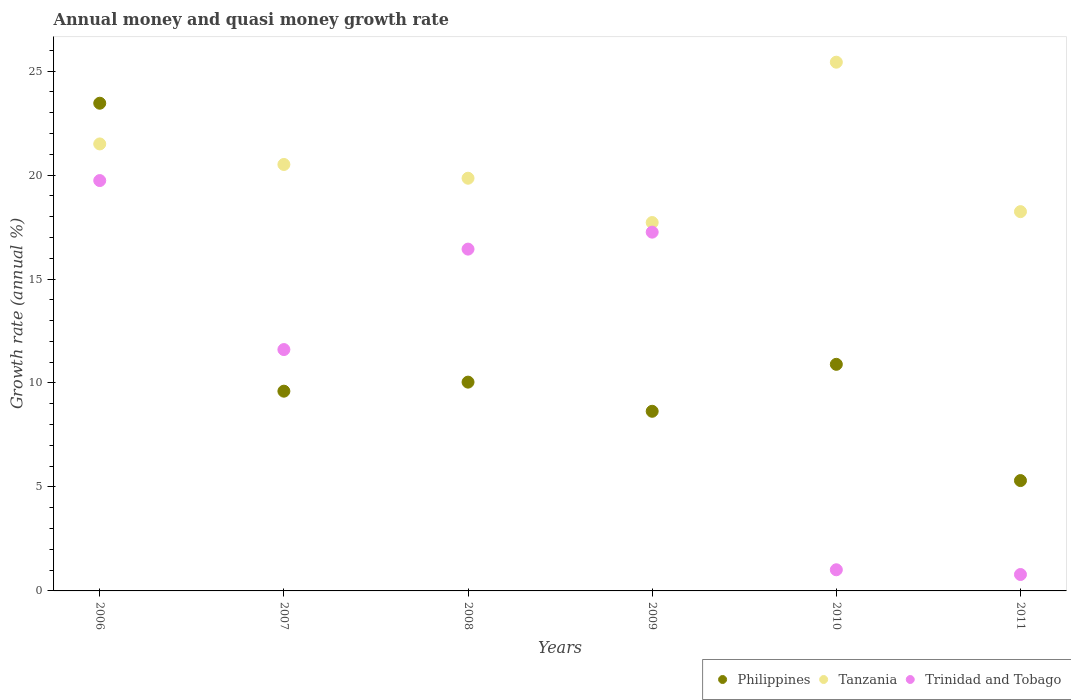What is the growth rate in Trinidad and Tobago in 2006?
Your answer should be compact. 19.73. Across all years, what is the maximum growth rate in Tanzania?
Keep it short and to the point. 25.43. Across all years, what is the minimum growth rate in Trinidad and Tobago?
Make the answer very short. 0.79. In which year was the growth rate in Tanzania maximum?
Your response must be concise. 2010. What is the total growth rate in Philippines in the graph?
Offer a terse response. 67.94. What is the difference between the growth rate in Tanzania in 2010 and that in 2011?
Give a very brief answer. 7.19. What is the difference between the growth rate in Trinidad and Tobago in 2006 and the growth rate in Tanzania in 2011?
Your response must be concise. 1.49. What is the average growth rate in Trinidad and Tobago per year?
Give a very brief answer. 11.14. In the year 2010, what is the difference between the growth rate in Philippines and growth rate in Tanzania?
Your answer should be compact. -14.53. What is the ratio of the growth rate in Philippines in 2006 to that in 2008?
Offer a very short reply. 2.34. Is the difference between the growth rate in Philippines in 2006 and 2011 greater than the difference between the growth rate in Tanzania in 2006 and 2011?
Keep it short and to the point. Yes. What is the difference between the highest and the second highest growth rate in Tanzania?
Offer a very short reply. 3.93. What is the difference between the highest and the lowest growth rate in Trinidad and Tobago?
Offer a very short reply. 18.94. In how many years, is the growth rate in Trinidad and Tobago greater than the average growth rate in Trinidad and Tobago taken over all years?
Offer a terse response. 4. Is the sum of the growth rate in Trinidad and Tobago in 2007 and 2010 greater than the maximum growth rate in Tanzania across all years?
Give a very brief answer. No. Is it the case that in every year, the sum of the growth rate in Trinidad and Tobago and growth rate in Philippines  is greater than the growth rate in Tanzania?
Your response must be concise. No. Does the growth rate in Tanzania monotonically increase over the years?
Provide a succinct answer. No. How many years are there in the graph?
Provide a succinct answer. 6. What is the difference between two consecutive major ticks on the Y-axis?
Your response must be concise. 5. Are the values on the major ticks of Y-axis written in scientific E-notation?
Offer a very short reply. No. Does the graph contain grids?
Your answer should be compact. No. What is the title of the graph?
Provide a succinct answer. Annual money and quasi money growth rate. Does "Venezuela" appear as one of the legend labels in the graph?
Make the answer very short. No. What is the label or title of the X-axis?
Your answer should be very brief. Years. What is the label or title of the Y-axis?
Give a very brief answer. Growth rate (annual %). What is the Growth rate (annual %) of Philippines in 2006?
Offer a very short reply. 23.45. What is the Growth rate (annual %) of Tanzania in 2006?
Provide a succinct answer. 21.5. What is the Growth rate (annual %) in Trinidad and Tobago in 2006?
Offer a very short reply. 19.73. What is the Growth rate (annual %) in Philippines in 2007?
Offer a very short reply. 9.61. What is the Growth rate (annual %) of Tanzania in 2007?
Your answer should be compact. 20.51. What is the Growth rate (annual %) of Trinidad and Tobago in 2007?
Give a very brief answer. 11.61. What is the Growth rate (annual %) in Philippines in 2008?
Your answer should be compact. 10.04. What is the Growth rate (annual %) of Tanzania in 2008?
Provide a short and direct response. 19.85. What is the Growth rate (annual %) of Trinidad and Tobago in 2008?
Make the answer very short. 16.44. What is the Growth rate (annual %) in Philippines in 2009?
Offer a very short reply. 8.64. What is the Growth rate (annual %) of Tanzania in 2009?
Your answer should be very brief. 17.72. What is the Growth rate (annual %) in Trinidad and Tobago in 2009?
Offer a very short reply. 17.25. What is the Growth rate (annual %) in Philippines in 2010?
Your answer should be compact. 10.9. What is the Growth rate (annual %) of Tanzania in 2010?
Keep it short and to the point. 25.43. What is the Growth rate (annual %) of Trinidad and Tobago in 2010?
Provide a short and direct response. 1.02. What is the Growth rate (annual %) of Philippines in 2011?
Give a very brief answer. 5.31. What is the Growth rate (annual %) in Tanzania in 2011?
Provide a short and direct response. 18.24. What is the Growth rate (annual %) of Trinidad and Tobago in 2011?
Offer a very short reply. 0.79. Across all years, what is the maximum Growth rate (annual %) of Philippines?
Your response must be concise. 23.45. Across all years, what is the maximum Growth rate (annual %) of Tanzania?
Your answer should be very brief. 25.43. Across all years, what is the maximum Growth rate (annual %) of Trinidad and Tobago?
Offer a terse response. 19.73. Across all years, what is the minimum Growth rate (annual %) of Philippines?
Your answer should be compact. 5.31. Across all years, what is the minimum Growth rate (annual %) of Tanzania?
Your response must be concise. 17.72. Across all years, what is the minimum Growth rate (annual %) in Trinidad and Tobago?
Ensure brevity in your answer.  0.79. What is the total Growth rate (annual %) of Philippines in the graph?
Provide a short and direct response. 67.94. What is the total Growth rate (annual %) in Tanzania in the graph?
Give a very brief answer. 123.23. What is the total Growth rate (annual %) of Trinidad and Tobago in the graph?
Your response must be concise. 66.84. What is the difference between the Growth rate (annual %) in Philippines in 2006 and that in 2007?
Your answer should be very brief. 13.85. What is the difference between the Growth rate (annual %) of Trinidad and Tobago in 2006 and that in 2007?
Give a very brief answer. 8.13. What is the difference between the Growth rate (annual %) in Philippines in 2006 and that in 2008?
Make the answer very short. 13.41. What is the difference between the Growth rate (annual %) of Tanzania in 2006 and that in 2008?
Give a very brief answer. 1.65. What is the difference between the Growth rate (annual %) in Trinidad and Tobago in 2006 and that in 2008?
Make the answer very short. 3.3. What is the difference between the Growth rate (annual %) in Philippines in 2006 and that in 2009?
Provide a succinct answer. 14.82. What is the difference between the Growth rate (annual %) in Tanzania in 2006 and that in 2009?
Ensure brevity in your answer.  3.78. What is the difference between the Growth rate (annual %) of Trinidad and Tobago in 2006 and that in 2009?
Make the answer very short. 2.48. What is the difference between the Growth rate (annual %) in Philippines in 2006 and that in 2010?
Your answer should be very brief. 12.56. What is the difference between the Growth rate (annual %) of Tanzania in 2006 and that in 2010?
Provide a short and direct response. -3.93. What is the difference between the Growth rate (annual %) of Trinidad and Tobago in 2006 and that in 2010?
Your answer should be very brief. 18.72. What is the difference between the Growth rate (annual %) in Philippines in 2006 and that in 2011?
Provide a succinct answer. 18.15. What is the difference between the Growth rate (annual %) in Tanzania in 2006 and that in 2011?
Ensure brevity in your answer.  3.26. What is the difference between the Growth rate (annual %) of Trinidad and Tobago in 2006 and that in 2011?
Give a very brief answer. 18.94. What is the difference between the Growth rate (annual %) in Philippines in 2007 and that in 2008?
Your answer should be compact. -0.44. What is the difference between the Growth rate (annual %) of Tanzania in 2007 and that in 2008?
Provide a succinct answer. 0.66. What is the difference between the Growth rate (annual %) of Trinidad and Tobago in 2007 and that in 2008?
Your answer should be compact. -4.83. What is the difference between the Growth rate (annual %) in Philippines in 2007 and that in 2009?
Offer a very short reply. 0.97. What is the difference between the Growth rate (annual %) in Tanzania in 2007 and that in 2009?
Provide a succinct answer. 2.79. What is the difference between the Growth rate (annual %) of Trinidad and Tobago in 2007 and that in 2009?
Make the answer very short. -5.65. What is the difference between the Growth rate (annual %) of Philippines in 2007 and that in 2010?
Make the answer very short. -1.29. What is the difference between the Growth rate (annual %) in Tanzania in 2007 and that in 2010?
Your response must be concise. -4.92. What is the difference between the Growth rate (annual %) of Trinidad and Tobago in 2007 and that in 2010?
Your answer should be compact. 10.59. What is the difference between the Growth rate (annual %) in Philippines in 2007 and that in 2011?
Make the answer very short. 4.3. What is the difference between the Growth rate (annual %) of Tanzania in 2007 and that in 2011?
Offer a very short reply. 2.27. What is the difference between the Growth rate (annual %) in Trinidad and Tobago in 2007 and that in 2011?
Offer a very short reply. 10.82. What is the difference between the Growth rate (annual %) in Philippines in 2008 and that in 2009?
Your answer should be compact. 1.4. What is the difference between the Growth rate (annual %) of Tanzania in 2008 and that in 2009?
Offer a very short reply. 2.13. What is the difference between the Growth rate (annual %) in Trinidad and Tobago in 2008 and that in 2009?
Make the answer very short. -0.82. What is the difference between the Growth rate (annual %) of Philippines in 2008 and that in 2010?
Offer a terse response. -0.86. What is the difference between the Growth rate (annual %) in Tanzania in 2008 and that in 2010?
Your answer should be compact. -5.58. What is the difference between the Growth rate (annual %) in Trinidad and Tobago in 2008 and that in 2010?
Keep it short and to the point. 15.42. What is the difference between the Growth rate (annual %) of Philippines in 2008 and that in 2011?
Provide a succinct answer. 4.73. What is the difference between the Growth rate (annual %) of Tanzania in 2008 and that in 2011?
Your response must be concise. 1.61. What is the difference between the Growth rate (annual %) in Trinidad and Tobago in 2008 and that in 2011?
Your response must be concise. 15.65. What is the difference between the Growth rate (annual %) of Philippines in 2009 and that in 2010?
Your answer should be very brief. -2.26. What is the difference between the Growth rate (annual %) of Tanzania in 2009 and that in 2010?
Keep it short and to the point. -7.71. What is the difference between the Growth rate (annual %) of Trinidad and Tobago in 2009 and that in 2010?
Your answer should be very brief. 16.24. What is the difference between the Growth rate (annual %) of Philippines in 2009 and that in 2011?
Offer a very short reply. 3.33. What is the difference between the Growth rate (annual %) in Tanzania in 2009 and that in 2011?
Keep it short and to the point. -0.52. What is the difference between the Growth rate (annual %) of Trinidad and Tobago in 2009 and that in 2011?
Your answer should be very brief. 16.46. What is the difference between the Growth rate (annual %) in Philippines in 2010 and that in 2011?
Ensure brevity in your answer.  5.59. What is the difference between the Growth rate (annual %) in Tanzania in 2010 and that in 2011?
Ensure brevity in your answer.  7.19. What is the difference between the Growth rate (annual %) in Trinidad and Tobago in 2010 and that in 2011?
Offer a terse response. 0.23. What is the difference between the Growth rate (annual %) of Philippines in 2006 and the Growth rate (annual %) of Tanzania in 2007?
Offer a terse response. 2.95. What is the difference between the Growth rate (annual %) of Philippines in 2006 and the Growth rate (annual %) of Trinidad and Tobago in 2007?
Ensure brevity in your answer.  11.85. What is the difference between the Growth rate (annual %) of Tanzania in 2006 and the Growth rate (annual %) of Trinidad and Tobago in 2007?
Your response must be concise. 9.89. What is the difference between the Growth rate (annual %) in Philippines in 2006 and the Growth rate (annual %) in Tanzania in 2008?
Provide a succinct answer. 3.61. What is the difference between the Growth rate (annual %) in Philippines in 2006 and the Growth rate (annual %) in Trinidad and Tobago in 2008?
Provide a short and direct response. 7.02. What is the difference between the Growth rate (annual %) in Tanzania in 2006 and the Growth rate (annual %) in Trinidad and Tobago in 2008?
Provide a short and direct response. 5.06. What is the difference between the Growth rate (annual %) in Philippines in 2006 and the Growth rate (annual %) in Tanzania in 2009?
Give a very brief answer. 5.74. What is the difference between the Growth rate (annual %) in Philippines in 2006 and the Growth rate (annual %) in Trinidad and Tobago in 2009?
Give a very brief answer. 6.2. What is the difference between the Growth rate (annual %) in Tanzania in 2006 and the Growth rate (annual %) in Trinidad and Tobago in 2009?
Ensure brevity in your answer.  4.24. What is the difference between the Growth rate (annual %) in Philippines in 2006 and the Growth rate (annual %) in Tanzania in 2010?
Provide a short and direct response. -1.97. What is the difference between the Growth rate (annual %) of Philippines in 2006 and the Growth rate (annual %) of Trinidad and Tobago in 2010?
Your response must be concise. 22.44. What is the difference between the Growth rate (annual %) of Tanzania in 2006 and the Growth rate (annual %) of Trinidad and Tobago in 2010?
Ensure brevity in your answer.  20.48. What is the difference between the Growth rate (annual %) of Philippines in 2006 and the Growth rate (annual %) of Tanzania in 2011?
Make the answer very short. 5.21. What is the difference between the Growth rate (annual %) in Philippines in 2006 and the Growth rate (annual %) in Trinidad and Tobago in 2011?
Make the answer very short. 22.66. What is the difference between the Growth rate (annual %) of Tanzania in 2006 and the Growth rate (annual %) of Trinidad and Tobago in 2011?
Keep it short and to the point. 20.71. What is the difference between the Growth rate (annual %) in Philippines in 2007 and the Growth rate (annual %) in Tanzania in 2008?
Offer a terse response. -10.24. What is the difference between the Growth rate (annual %) in Philippines in 2007 and the Growth rate (annual %) in Trinidad and Tobago in 2008?
Offer a terse response. -6.83. What is the difference between the Growth rate (annual %) in Tanzania in 2007 and the Growth rate (annual %) in Trinidad and Tobago in 2008?
Provide a succinct answer. 4.07. What is the difference between the Growth rate (annual %) of Philippines in 2007 and the Growth rate (annual %) of Tanzania in 2009?
Ensure brevity in your answer.  -8.11. What is the difference between the Growth rate (annual %) of Philippines in 2007 and the Growth rate (annual %) of Trinidad and Tobago in 2009?
Your answer should be very brief. -7.65. What is the difference between the Growth rate (annual %) of Tanzania in 2007 and the Growth rate (annual %) of Trinidad and Tobago in 2009?
Make the answer very short. 3.25. What is the difference between the Growth rate (annual %) in Philippines in 2007 and the Growth rate (annual %) in Tanzania in 2010?
Keep it short and to the point. -15.82. What is the difference between the Growth rate (annual %) in Philippines in 2007 and the Growth rate (annual %) in Trinidad and Tobago in 2010?
Your answer should be very brief. 8.59. What is the difference between the Growth rate (annual %) of Tanzania in 2007 and the Growth rate (annual %) of Trinidad and Tobago in 2010?
Provide a succinct answer. 19.49. What is the difference between the Growth rate (annual %) of Philippines in 2007 and the Growth rate (annual %) of Tanzania in 2011?
Provide a succinct answer. -8.63. What is the difference between the Growth rate (annual %) in Philippines in 2007 and the Growth rate (annual %) in Trinidad and Tobago in 2011?
Offer a very short reply. 8.82. What is the difference between the Growth rate (annual %) of Tanzania in 2007 and the Growth rate (annual %) of Trinidad and Tobago in 2011?
Your answer should be compact. 19.72. What is the difference between the Growth rate (annual %) of Philippines in 2008 and the Growth rate (annual %) of Tanzania in 2009?
Your answer should be compact. -7.67. What is the difference between the Growth rate (annual %) of Philippines in 2008 and the Growth rate (annual %) of Trinidad and Tobago in 2009?
Your answer should be very brief. -7.21. What is the difference between the Growth rate (annual %) in Tanzania in 2008 and the Growth rate (annual %) in Trinidad and Tobago in 2009?
Provide a short and direct response. 2.59. What is the difference between the Growth rate (annual %) of Philippines in 2008 and the Growth rate (annual %) of Tanzania in 2010?
Provide a short and direct response. -15.39. What is the difference between the Growth rate (annual %) in Philippines in 2008 and the Growth rate (annual %) in Trinidad and Tobago in 2010?
Your response must be concise. 9.02. What is the difference between the Growth rate (annual %) in Tanzania in 2008 and the Growth rate (annual %) in Trinidad and Tobago in 2010?
Ensure brevity in your answer.  18.83. What is the difference between the Growth rate (annual %) in Philippines in 2008 and the Growth rate (annual %) in Tanzania in 2011?
Provide a short and direct response. -8.2. What is the difference between the Growth rate (annual %) in Philippines in 2008 and the Growth rate (annual %) in Trinidad and Tobago in 2011?
Provide a succinct answer. 9.25. What is the difference between the Growth rate (annual %) in Tanzania in 2008 and the Growth rate (annual %) in Trinidad and Tobago in 2011?
Your response must be concise. 19.06. What is the difference between the Growth rate (annual %) of Philippines in 2009 and the Growth rate (annual %) of Tanzania in 2010?
Give a very brief answer. -16.79. What is the difference between the Growth rate (annual %) of Philippines in 2009 and the Growth rate (annual %) of Trinidad and Tobago in 2010?
Provide a succinct answer. 7.62. What is the difference between the Growth rate (annual %) in Tanzania in 2009 and the Growth rate (annual %) in Trinidad and Tobago in 2010?
Offer a very short reply. 16.7. What is the difference between the Growth rate (annual %) of Philippines in 2009 and the Growth rate (annual %) of Tanzania in 2011?
Offer a terse response. -9.6. What is the difference between the Growth rate (annual %) of Philippines in 2009 and the Growth rate (annual %) of Trinidad and Tobago in 2011?
Your answer should be compact. 7.85. What is the difference between the Growth rate (annual %) in Tanzania in 2009 and the Growth rate (annual %) in Trinidad and Tobago in 2011?
Keep it short and to the point. 16.93. What is the difference between the Growth rate (annual %) in Philippines in 2010 and the Growth rate (annual %) in Tanzania in 2011?
Your answer should be very brief. -7.34. What is the difference between the Growth rate (annual %) of Philippines in 2010 and the Growth rate (annual %) of Trinidad and Tobago in 2011?
Give a very brief answer. 10.11. What is the difference between the Growth rate (annual %) of Tanzania in 2010 and the Growth rate (annual %) of Trinidad and Tobago in 2011?
Provide a short and direct response. 24.64. What is the average Growth rate (annual %) of Philippines per year?
Provide a succinct answer. 11.32. What is the average Growth rate (annual %) of Tanzania per year?
Your response must be concise. 20.54. What is the average Growth rate (annual %) of Trinidad and Tobago per year?
Provide a succinct answer. 11.14. In the year 2006, what is the difference between the Growth rate (annual %) in Philippines and Growth rate (annual %) in Tanzania?
Your answer should be compact. 1.96. In the year 2006, what is the difference between the Growth rate (annual %) of Philippines and Growth rate (annual %) of Trinidad and Tobago?
Provide a short and direct response. 3.72. In the year 2006, what is the difference between the Growth rate (annual %) in Tanzania and Growth rate (annual %) in Trinidad and Tobago?
Give a very brief answer. 1.76. In the year 2007, what is the difference between the Growth rate (annual %) in Philippines and Growth rate (annual %) in Tanzania?
Ensure brevity in your answer.  -10.9. In the year 2007, what is the difference between the Growth rate (annual %) in Philippines and Growth rate (annual %) in Trinidad and Tobago?
Ensure brevity in your answer.  -2. In the year 2007, what is the difference between the Growth rate (annual %) of Tanzania and Growth rate (annual %) of Trinidad and Tobago?
Your response must be concise. 8.9. In the year 2008, what is the difference between the Growth rate (annual %) of Philippines and Growth rate (annual %) of Tanzania?
Give a very brief answer. -9.81. In the year 2008, what is the difference between the Growth rate (annual %) in Philippines and Growth rate (annual %) in Trinidad and Tobago?
Your answer should be compact. -6.4. In the year 2008, what is the difference between the Growth rate (annual %) in Tanzania and Growth rate (annual %) in Trinidad and Tobago?
Provide a short and direct response. 3.41. In the year 2009, what is the difference between the Growth rate (annual %) of Philippines and Growth rate (annual %) of Tanzania?
Give a very brief answer. -9.08. In the year 2009, what is the difference between the Growth rate (annual %) of Philippines and Growth rate (annual %) of Trinidad and Tobago?
Offer a terse response. -8.62. In the year 2009, what is the difference between the Growth rate (annual %) of Tanzania and Growth rate (annual %) of Trinidad and Tobago?
Your answer should be compact. 0.46. In the year 2010, what is the difference between the Growth rate (annual %) in Philippines and Growth rate (annual %) in Tanzania?
Keep it short and to the point. -14.53. In the year 2010, what is the difference between the Growth rate (annual %) in Philippines and Growth rate (annual %) in Trinidad and Tobago?
Provide a succinct answer. 9.88. In the year 2010, what is the difference between the Growth rate (annual %) of Tanzania and Growth rate (annual %) of Trinidad and Tobago?
Offer a very short reply. 24.41. In the year 2011, what is the difference between the Growth rate (annual %) in Philippines and Growth rate (annual %) in Tanzania?
Make the answer very short. -12.93. In the year 2011, what is the difference between the Growth rate (annual %) in Philippines and Growth rate (annual %) in Trinidad and Tobago?
Make the answer very short. 4.52. In the year 2011, what is the difference between the Growth rate (annual %) in Tanzania and Growth rate (annual %) in Trinidad and Tobago?
Ensure brevity in your answer.  17.45. What is the ratio of the Growth rate (annual %) of Philippines in 2006 to that in 2007?
Offer a terse response. 2.44. What is the ratio of the Growth rate (annual %) of Tanzania in 2006 to that in 2007?
Offer a terse response. 1.05. What is the ratio of the Growth rate (annual %) of Trinidad and Tobago in 2006 to that in 2007?
Your response must be concise. 1.7. What is the ratio of the Growth rate (annual %) in Philippines in 2006 to that in 2008?
Provide a succinct answer. 2.34. What is the ratio of the Growth rate (annual %) of Tanzania in 2006 to that in 2008?
Offer a very short reply. 1.08. What is the ratio of the Growth rate (annual %) of Trinidad and Tobago in 2006 to that in 2008?
Ensure brevity in your answer.  1.2. What is the ratio of the Growth rate (annual %) of Philippines in 2006 to that in 2009?
Ensure brevity in your answer.  2.71. What is the ratio of the Growth rate (annual %) of Tanzania in 2006 to that in 2009?
Ensure brevity in your answer.  1.21. What is the ratio of the Growth rate (annual %) of Trinidad and Tobago in 2006 to that in 2009?
Give a very brief answer. 1.14. What is the ratio of the Growth rate (annual %) of Philippines in 2006 to that in 2010?
Ensure brevity in your answer.  2.15. What is the ratio of the Growth rate (annual %) in Tanzania in 2006 to that in 2010?
Provide a succinct answer. 0.85. What is the ratio of the Growth rate (annual %) of Trinidad and Tobago in 2006 to that in 2010?
Offer a terse response. 19.4. What is the ratio of the Growth rate (annual %) in Philippines in 2006 to that in 2011?
Provide a short and direct response. 4.42. What is the ratio of the Growth rate (annual %) in Tanzania in 2006 to that in 2011?
Give a very brief answer. 1.18. What is the ratio of the Growth rate (annual %) of Trinidad and Tobago in 2006 to that in 2011?
Offer a terse response. 25. What is the ratio of the Growth rate (annual %) of Philippines in 2007 to that in 2008?
Provide a short and direct response. 0.96. What is the ratio of the Growth rate (annual %) in Trinidad and Tobago in 2007 to that in 2008?
Offer a terse response. 0.71. What is the ratio of the Growth rate (annual %) of Philippines in 2007 to that in 2009?
Your answer should be very brief. 1.11. What is the ratio of the Growth rate (annual %) of Tanzania in 2007 to that in 2009?
Your answer should be very brief. 1.16. What is the ratio of the Growth rate (annual %) of Trinidad and Tobago in 2007 to that in 2009?
Offer a very short reply. 0.67. What is the ratio of the Growth rate (annual %) in Philippines in 2007 to that in 2010?
Your answer should be compact. 0.88. What is the ratio of the Growth rate (annual %) in Tanzania in 2007 to that in 2010?
Make the answer very short. 0.81. What is the ratio of the Growth rate (annual %) of Trinidad and Tobago in 2007 to that in 2010?
Offer a terse response. 11.41. What is the ratio of the Growth rate (annual %) in Philippines in 2007 to that in 2011?
Your answer should be very brief. 1.81. What is the ratio of the Growth rate (annual %) in Tanzania in 2007 to that in 2011?
Provide a short and direct response. 1.12. What is the ratio of the Growth rate (annual %) in Trinidad and Tobago in 2007 to that in 2011?
Give a very brief answer. 14.7. What is the ratio of the Growth rate (annual %) in Philippines in 2008 to that in 2009?
Offer a very short reply. 1.16. What is the ratio of the Growth rate (annual %) of Tanzania in 2008 to that in 2009?
Your response must be concise. 1.12. What is the ratio of the Growth rate (annual %) in Trinidad and Tobago in 2008 to that in 2009?
Provide a short and direct response. 0.95. What is the ratio of the Growth rate (annual %) of Philippines in 2008 to that in 2010?
Your response must be concise. 0.92. What is the ratio of the Growth rate (annual %) of Tanzania in 2008 to that in 2010?
Give a very brief answer. 0.78. What is the ratio of the Growth rate (annual %) in Trinidad and Tobago in 2008 to that in 2010?
Your answer should be very brief. 16.16. What is the ratio of the Growth rate (annual %) in Philippines in 2008 to that in 2011?
Your response must be concise. 1.89. What is the ratio of the Growth rate (annual %) of Tanzania in 2008 to that in 2011?
Offer a very short reply. 1.09. What is the ratio of the Growth rate (annual %) of Trinidad and Tobago in 2008 to that in 2011?
Make the answer very short. 20.82. What is the ratio of the Growth rate (annual %) of Philippines in 2009 to that in 2010?
Your answer should be very brief. 0.79. What is the ratio of the Growth rate (annual %) in Tanzania in 2009 to that in 2010?
Your response must be concise. 0.7. What is the ratio of the Growth rate (annual %) in Trinidad and Tobago in 2009 to that in 2010?
Provide a succinct answer. 16.96. What is the ratio of the Growth rate (annual %) in Philippines in 2009 to that in 2011?
Provide a succinct answer. 1.63. What is the ratio of the Growth rate (annual %) of Tanzania in 2009 to that in 2011?
Keep it short and to the point. 0.97. What is the ratio of the Growth rate (annual %) in Trinidad and Tobago in 2009 to that in 2011?
Offer a very short reply. 21.86. What is the ratio of the Growth rate (annual %) of Philippines in 2010 to that in 2011?
Provide a succinct answer. 2.05. What is the ratio of the Growth rate (annual %) in Tanzania in 2010 to that in 2011?
Give a very brief answer. 1.39. What is the ratio of the Growth rate (annual %) of Trinidad and Tobago in 2010 to that in 2011?
Your answer should be very brief. 1.29. What is the difference between the highest and the second highest Growth rate (annual %) of Philippines?
Provide a succinct answer. 12.56. What is the difference between the highest and the second highest Growth rate (annual %) of Tanzania?
Offer a very short reply. 3.93. What is the difference between the highest and the second highest Growth rate (annual %) in Trinidad and Tobago?
Offer a terse response. 2.48. What is the difference between the highest and the lowest Growth rate (annual %) of Philippines?
Offer a very short reply. 18.15. What is the difference between the highest and the lowest Growth rate (annual %) of Tanzania?
Your answer should be compact. 7.71. What is the difference between the highest and the lowest Growth rate (annual %) of Trinidad and Tobago?
Ensure brevity in your answer.  18.94. 